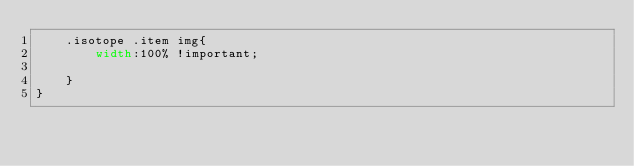Convert code to text. <code><loc_0><loc_0><loc_500><loc_500><_CSS_>    .isotope .item img{
        width:100% !important;
       
    }
}</code> 